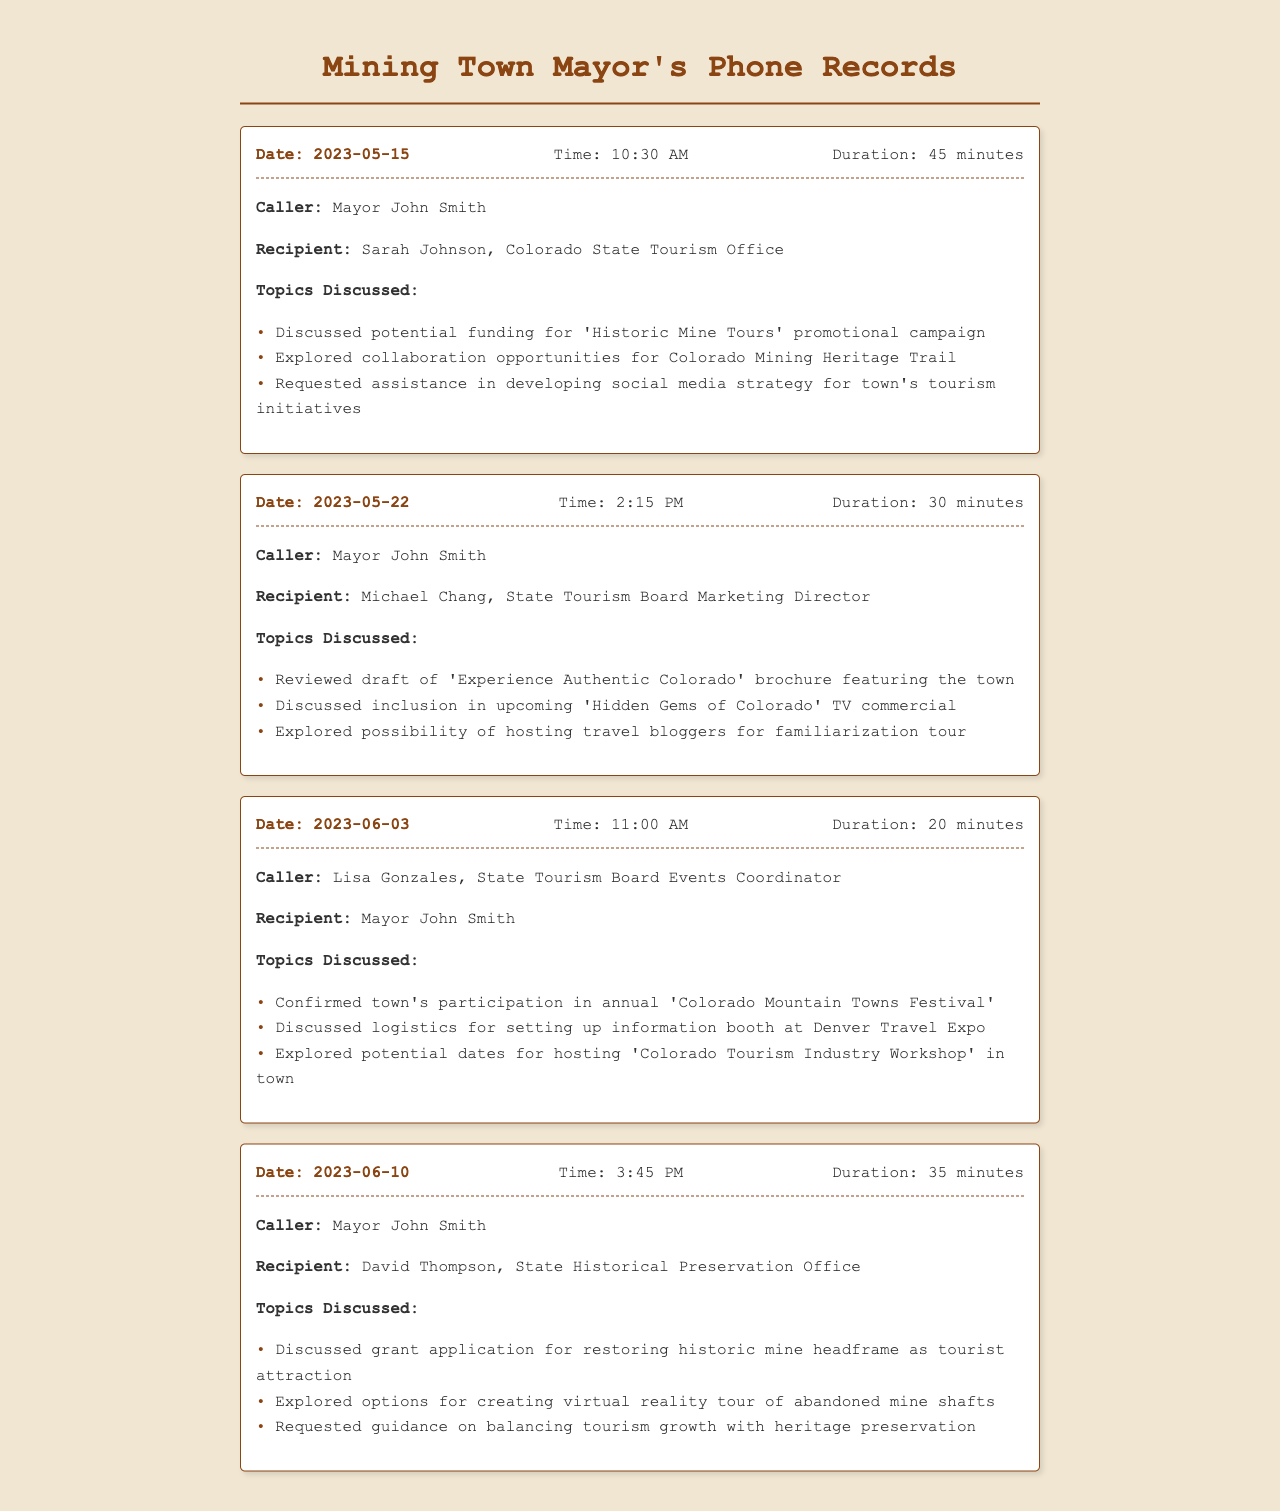what is the first date recorded in the phone records? The first date listed in the records is the initial phone call between the mayor and the state tourism office representative, which is May 15, 2023.
Answer: May 15, 2023 who did the mayor speak to on June 3, 2023? The record on June 3, 2023, indicates the mayor spoke to Lisa Gonzales, who is identified as the State Tourism Board Events Coordinator.
Answer: Lisa Gonzales how many minutes did the conversation on May 22, 2023, last? The conversation on May 22, 2023, is noted to have lasted for 30 minutes, as stated in the record.
Answer: 30 minutes what promotional campaign was discussed on May 15, 2023? During the call on May 15, 2023, the mayor and Sarah Johnson discussed potential funding for the 'Historic Mine Tours' promotional campaign.
Answer: 'Historic Mine Tours' which topic was explored for June 10, 2023, conversation? The discussions held on June 10, 2023, with David Thompson included options for creating a virtual reality tour of abandoned mine shafts.
Answer: virtual reality tour what event is the town participating in according to the June 3, 2023 record? The record indicates that the town confirmed participation in the annual 'Colorado Mountain Towns Festival.'
Answer: Colorado Mountain Towns Festival who was the recipient of the first call made by the mayor? The first call made by the mayor was to Sarah Johnson, from the Colorado State Tourism Office.
Answer: Sarah Johnson what was the main concern raised in the June 10, 2023 discussion? In the June 10 discussion, the mayor requested guidance on balancing tourism growth with heritage preservation, showcasing a concern about maintaining the town's heritage.
Answer: balancing tourism growth with heritage preservation 